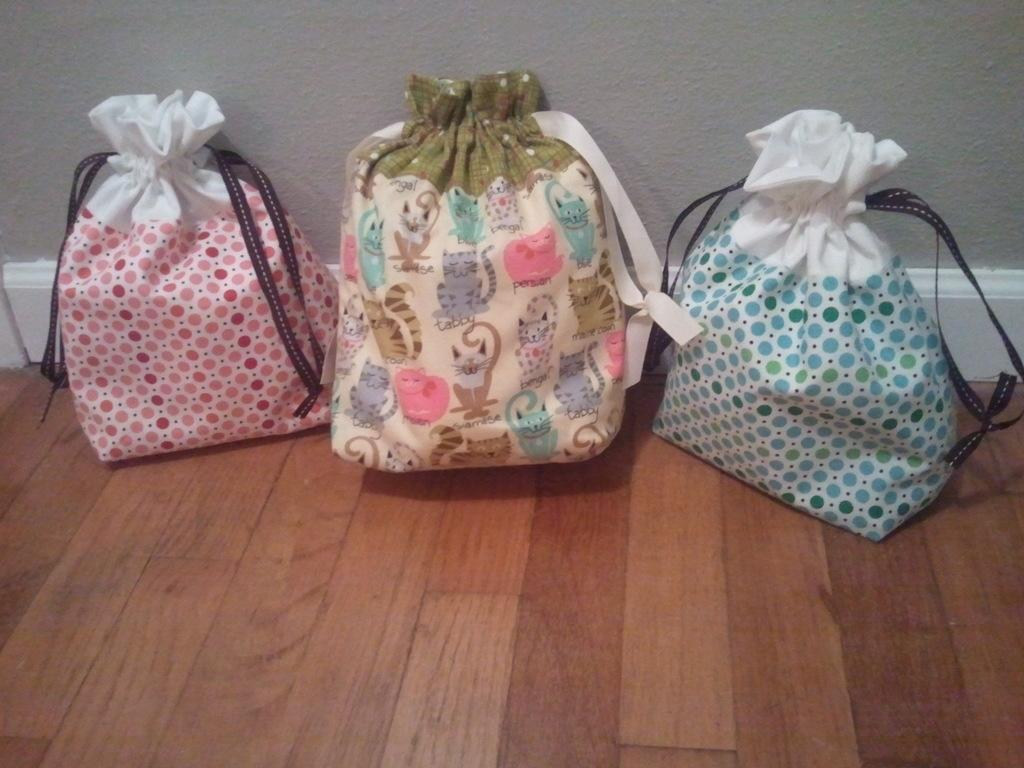What objects are present in the image? There are bags in different colors in the image. How are the bags arranged in the image? The bags are arranged on a wooden floor. What can be seen in the background of the image? There is a white color wall in the background of the image. What type of advertisement is being displayed on the bags in the image? There is no advertisement present on the bags in the image; they are simply bags in different colors. 